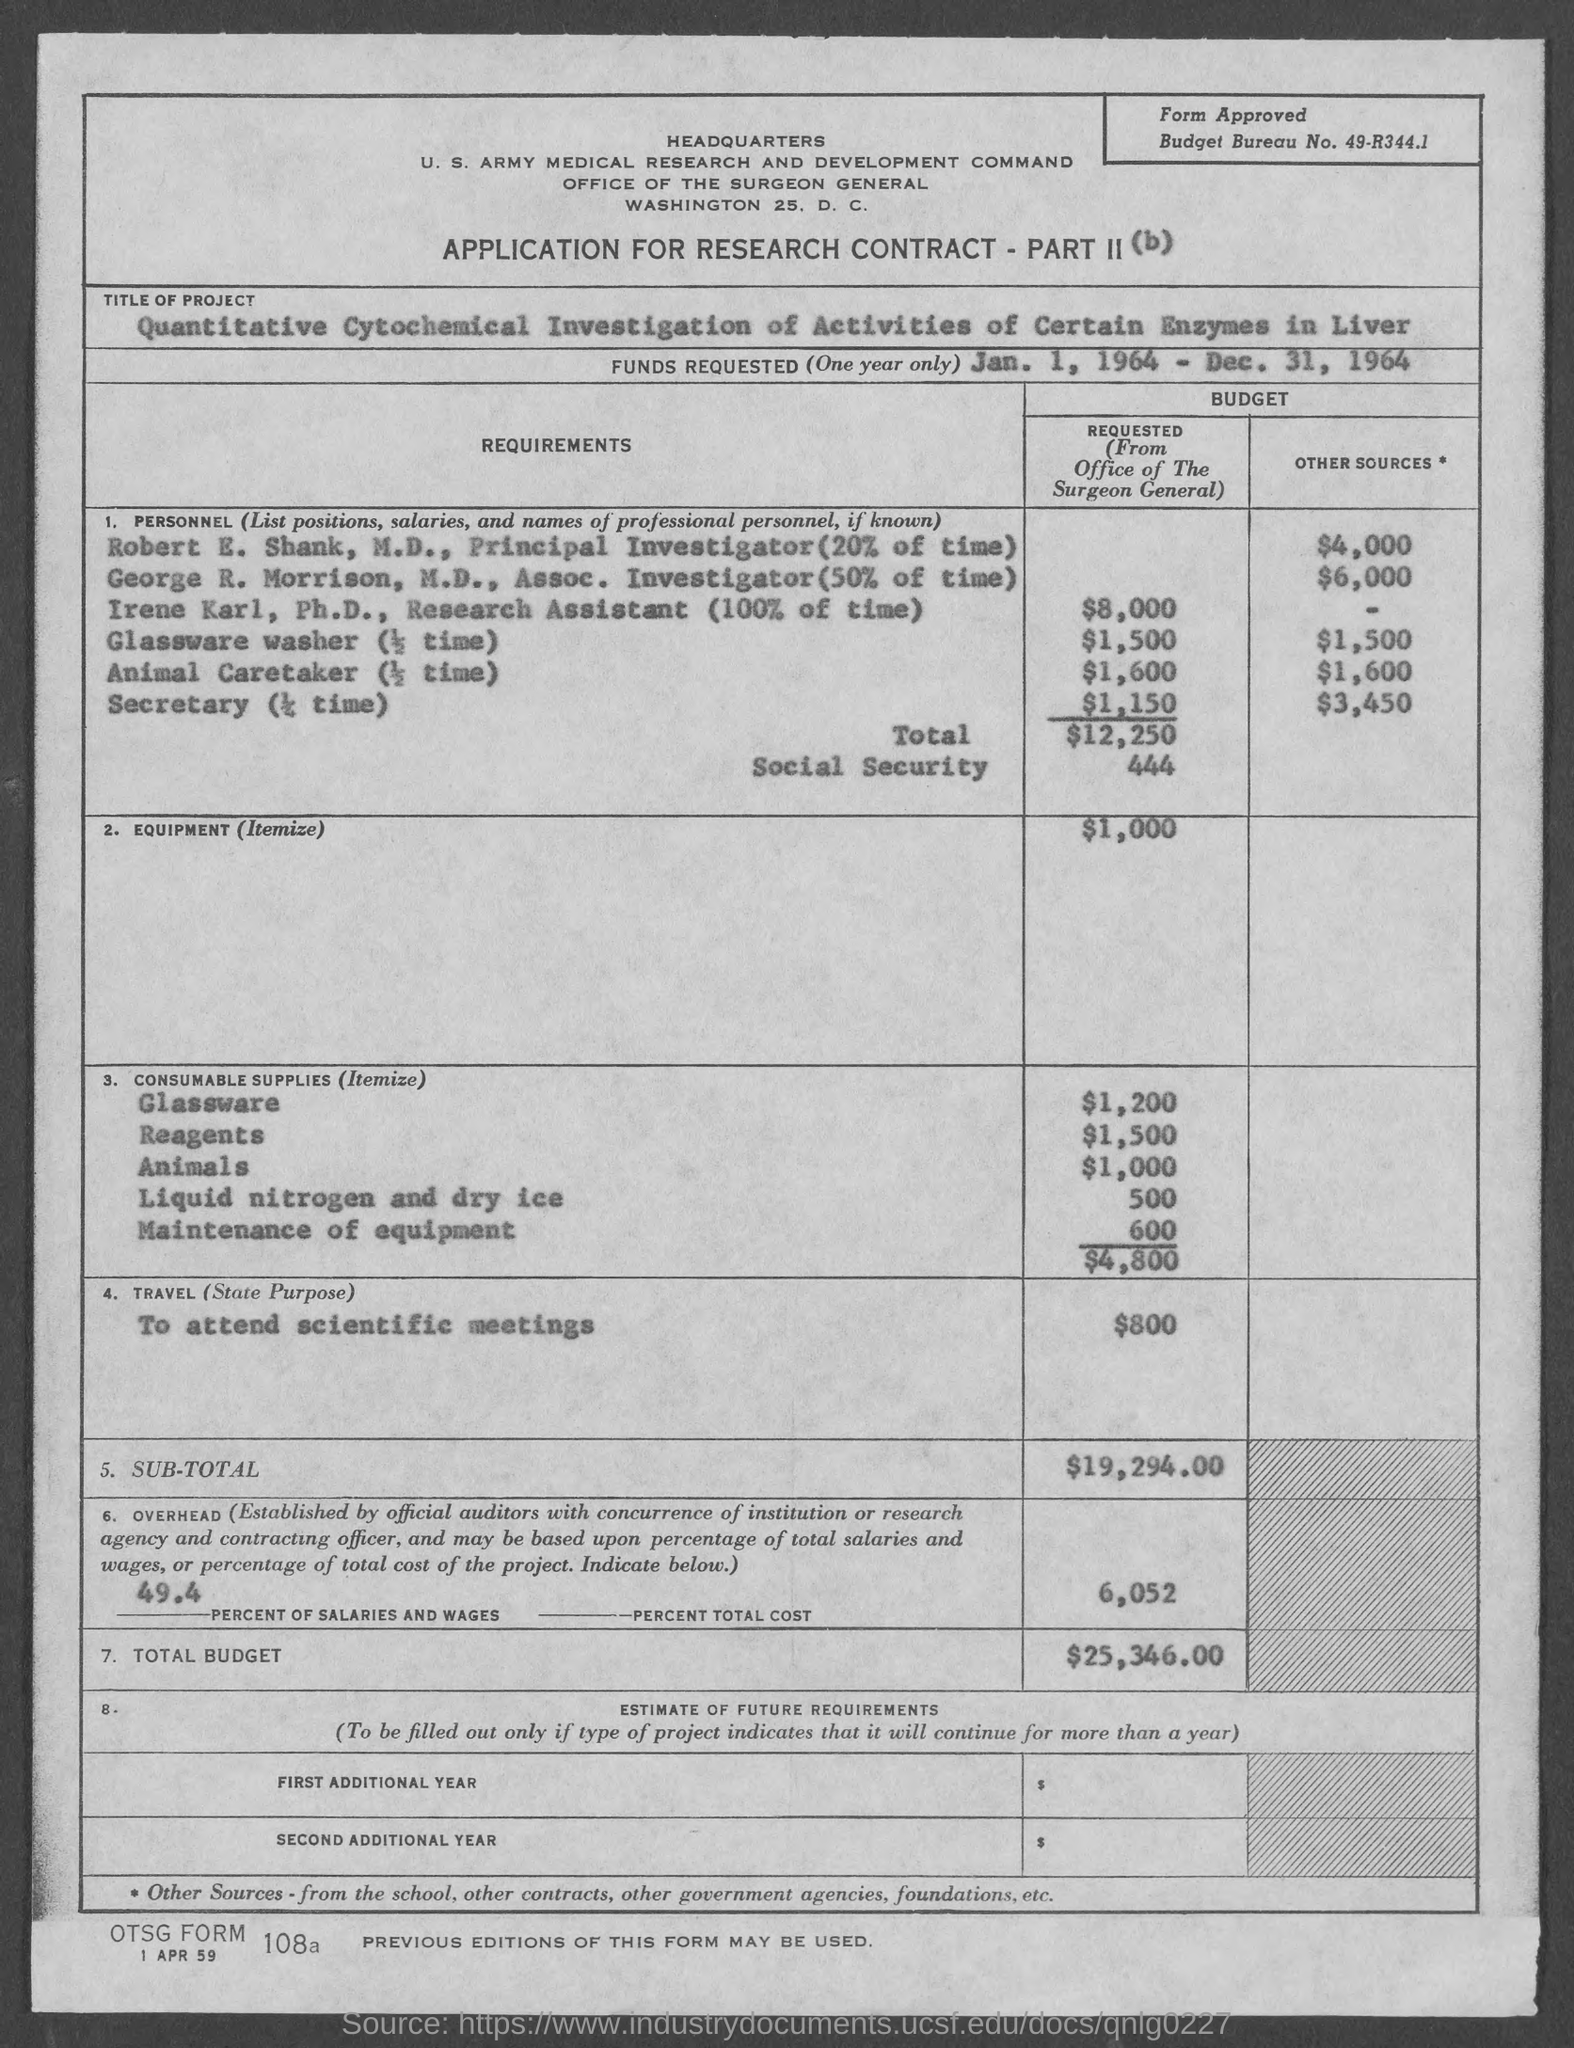Outline some significant characteristics in this image. The budget bureau number is 49-R344.1. 